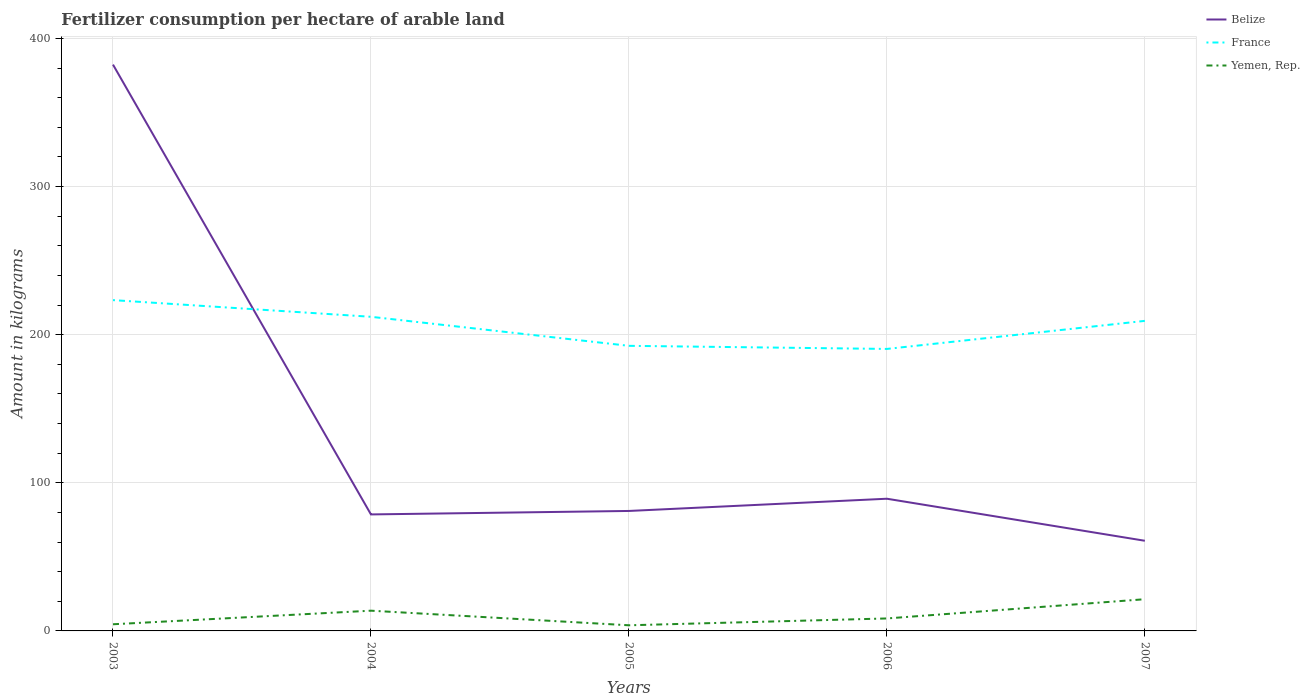How many different coloured lines are there?
Offer a very short reply. 3. Does the line corresponding to Belize intersect with the line corresponding to Yemen, Rep.?
Your answer should be compact. No. Across all years, what is the maximum amount of fertilizer consumption in France?
Your answer should be compact. 190.39. In which year was the amount of fertilizer consumption in Yemen, Rep. maximum?
Your response must be concise. 2005. What is the total amount of fertilizer consumption in Belize in the graph?
Ensure brevity in your answer.  321.5. What is the difference between the highest and the second highest amount of fertilizer consumption in France?
Your response must be concise. 32.96. What is the difference between the highest and the lowest amount of fertilizer consumption in France?
Your answer should be very brief. 3. How many lines are there?
Keep it short and to the point. 3. Are the values on the major ticks of Y-axis written in scientific E-notation?
Your answer should be very brief. No. How many legend labels are there?
Keep it short and to the point. 3. What is the title of the graph?
Keep it short and to the point. Fertilizer consumption per hectare of arable land. What is the label or title of the Y-axis?
Keep it short and to the point. Amount in kilograms. What is the Amount in kilograms of Belize in 2003?
Keep it short and to the point. 382.37. What is the Amount in kilograms of France in 2003?
Your answer should be very brief. 223.36. What is the Amount in kilograms in Yemen, Rep. in 2003?
Provide a short and direct response. 4.5. What is the Amount in kilograms of Belize in 2004?
Provide a short and direct response. 78.66. What is the Amount in kilograms of France in 2004?
Keep it short and to the point. 212.1. What is the Amount in kilograms in Yemen, Rep. in 2004?
Offer a terse response. 13.66. What is the Amount in kilograms in France in 2005?
Offer a terse response. 192.49. What is the Amount in kilograms of Yemen, Rep. in 2005?
Give a very brief answer. 3.81. What is the Amount in kilograms in Belize in 2006?
Offer a terse response. 89.26. What is the Amount in kilograms of France in 2006?
Offer a very short reply. 190.39. What is the Amount in kilograms of Yemen, Rep. in 2006?
Your answer should be compact. 8.42. What is the Amount in kilograms of Belize in 2007?
Give a very brief answer. 60.87. What is the Amount in kilograms in France in 2007?
Offer a very short reply. 209.34. What is the Amount in kilograms in Yemen, Rep. in 2007?
Ensure brevity in your answer.  21.41. Across all years, what is the maximum Amount in kilograms of Belize?
Your answer should be compact. 382.37. Across all years, what is the maximum Amount in kilograms of France?
Offer a terse response. 223.36. Across all years, what is the maximum Amount in kilograms in Yemen, Rep.?
Offer a very short reply. 21.41. Across all years, what is the minimum Amount in kilograms of Belize?
Ensure brevity in your answer.  60.87. Across all years, what is the minimum Amount in kilograms in France?
Keep it short and to the point. 190.39. Across all years, what is the minimum Amount in kilograms of Yemen, Rep.?
Your answer should be very brief. 3.81. What is the total Amount in kilograms in Belize in the graph?
Provide a short and direct response. 692.16. What is the total Amount in kilograms in France in the graph?
Give a very brief answer. 1027.69. What is the total Amount in kilograms of Yemen, Rep. in the graph?
Provide a succinct answer. 51.8. What is the difference between the Amount in kilograms of Belize in 2003 and that in 2004?
Provide a succinct answer. 303.71. What is the difference between the Amount in kilograms of France in 2003 and that in 2004?
Your response must be concise. 11.25. What is the difference between the Amount in kilograms of Yemen, Rep. in 2003 and that in 2004?
Keep it short and to the point. -9.17. What is the difference between the Amount in kilograms in Belize in 2003 and that in 2005?
Keep it short and to the point. 301.37. What is the difference between the Amount in kilograms in France in 2003 and that in 2005?
Offer a terse response. 30.86. What is the difference between the Amount in kilograms of Yemen, Rep. in 2003 and that in 2005?
Your response must be concise. 0.69. What is the difference between the Amount in kilograms in Belize in 2003 and that in 2006?
Keep it short and to the point. 293.11. What is the difference between the Amount in kilograms in France in 2003 and that in 2006?
Provide a short and direct response. 32.96. What is the difference between the Amount in kilograms in Yemen, Rep. in 2003 and that in 2006?
Your response must be concise. -3.93. What is the difference between the Amount in kilograms of Belize in 2003 and that in 2007?
Your answer should be compact. 321.5. What is the difference between the Amount in kilograms in France in 2003 and that in 2007?
Keep it short and to the point. 14.01. What is the difference between the Amount in kilograms in Yemen, Rep. in 2003 and that in 2007?
Ensure brevity in your answer.  -16.91. What is the difference between the Amount in kilograms in Belize in 2004 and that in 2005?
Provide a short and direct response. -2.34. What is the difference between the Amount in kilograms in France in 2004 and that in 2005?
Make the answer very short. 19.61. What is the difference between the Amount in kilograms in Yemen, Rep. in 2004 and that in 2005?
Your response must be concise. 9.86. What is the difference between the Amount in kilograms in France in 2004 and that in 2006?
Provide a short and direct response. 21.71. What is the difference between the Amount in kilograms in Yemen, Rep. in 2004 and that in 2006?
Your answer should be compact. 5.24. What is the difference between the Amount in kilograms in Belize in 2004 and that in 2007?
Your answer should be compact. 17.79. What is the difference between the Amount in kilograms of France in 2004 and that in 2007?
Your answer should be very brief. 2.76. What is the difference between the Amount in kilograms of Yemen, Rep. in 2004 and that in 2007?
Make the answer very short. -7.74. What is the difference between the Amount in kilograms in Belize in 2005 and that in 2006?
Provide a succinct answer. -8.26. What is the difference between the Amount in kilograms of Yemen, Rep. in 2005 and that in 2006?
Provide a succinct answer. -4.62. What is the difference between the Amount in kilograms of Belize in 2005 and that in 2007?
Offer a very short reply. 20.13. What is the difference between the Amount in kilograms in France in 2005 and that in 2007?
Offer a terse response. -16.85. What is the difference between the Amount in kilograms of Yemen, Rep. in 2005 and that in 2007?
Your answer should be compact. -17.6. What is the difference between the Amount in kilograms of Belize in 2006 and that in 2007?
Offer a very short reply. 28.39. What is the difference between the Amount in kilograms of France in 2006 and that in 2007?
Your response must be concise. -18.95. What is the difference between the Amount in kilograms in Yemen, Rep. in 2006 and that in 2007?
Provide a short and direct response. -12.98. What is the difference between the Amount in kilograms in Belize in 2003 and the Amount in kilograms in France in 2004?
Keep it short and to the point. 170.27. What is the difference between the Amount in kilograms of Belize in 2003 and the Amount in kilograms of Yemen, Rep. in 2004?
Your answer should be very brief. 368.71. What is the difference between the Amount in kilograms in France in 2003 and the Amount in kilograms in Yemen, Rep. in 2004?
Your response must be concise. 209.69. What is the difference between the Amount in kilograms of Belize in 2003 and the Amount in kilograms of France in 2005?
Keep it short and to the point. 189.88. What is the difference between the Amount in kilograms of Belize in 2003 and the Amount in kilograms of Yemen, Rep. in 2005?
Give a very brief answer. 378.56. What is the difference between the Amount in kilograms in France in 2003 and the Amount in kilograms in Yemen, Rep. in 2005?
Give a very brief answer. 219.55. What is the difference between the Amount in kilograms of Belize in 2003 and the Amount in kilograms of France in 2006?
Your answer should be compact. 191.98. What is the difference between the Amount in kilograms of Belize in 2003 and the Amount in kilograms of Yemen, Rep. in 2006?
Give a very brief answer. 373.95. What is the difference between the Amount in kilograms of France in 2003 and the Amount in kilograms of Yemen, Rep. in 2006?
Offer a terse response. 214.93. What is the difference between the Amount in kilograms in Belize in 2003 and the Amount in kilograms in France in 2007?
Your answer should be very brief. 173.03. What is the difference between the Amount in kilograms of Belize in 2003 and the Amount in kilograms of Yemen, Rep. in 2007?
Provide a succinct answer. 360.96. What is the difference between the Amount in kilograms of France in 2003 and the Amount in kilograms of Yemen, Rep. in 2007?
Your response must be concise. 201.95. What is the difference between the Amount in kilograms in Belize in 2004 and the Amount in kilograms in France in 2005?
Give a very brief answer. -113.84. What is the difference between the Amount in kilograms in Belize in 2004 and the Amount in kilograms in Yemen, Rep. in 2005?
Keep it short and to the point. 74.85. What is the difference between the Amount in kilograms in France in 2004 and the Amount in kilograms in Yemen, Rep. in 2005?
Your answer should be compact. 208.3. What is the difference between the Amount in kilograms in Belize in 2004 and the Amount in kilograms in France in 2006?
Offer a very short reply. -111.74. What is the difference between the Amount in kilograms in Belize in 2004 and the Amount in kilograms in Yemen, Rep. in 2006?
Make the answer very short. 70.23. What is the difference between the Amount in kilograms in France in 2004 and the Amount in kilograms in Yemen, Rep. in 2006?
Offer a very short reply. 203.68. What is the difference between the Amount in kilograms in Belize in 2004 and the Amount in kilograms in France in 2007?
Keep it short and to the point. -130.69. What is the difference between the Amount in kilograms in Belize in 2004 and the Amount in kilograms in Yemen, Rep. in 2007?
Your answer should be compact. 57.25. What is the difference between the Amount in kilograms in France in 2004 and the Amount in kilograms in Yemen, Rep. in 2007?
Make the answer very short. 190.7. What is the difference between the Amount in kilograms of Belize in 2005 and the Amount in kilograms of France in 2006?
Your response must be concise. -109.39. What is the difference between the Amount in kilograms of Belize in 2005 and the Amount in kilograms of Yemen, Rep. in 2006?
Offer a terse response. 72.58. What is the difference between the Amount in kilograms of France in 2005 and the Amount in kilograms of Yemen, Rep. in 2006?
Your answer should be compact. 184.07. What is the difference between the Amount in kilograms in Belize in 2005 and the Amount in kilograms in France in 2007?
Your response must be concise. -128.34. What is the difference between the Amount in kilograms of Belize in 2005 and the Amount in kilograms of Yemen, Rep. in 2007?
Give a very brief answer. 59.59. What is the difference between the Amount in kilograms of France in 2005 and the Amount in kilograms of Yemen, Rep. in 2007?
Ensure brevity in your answer.  171.09. What is the difference between the Amount in kilograms in Belize in 2006 and the Amount in kilograms in France in 2007?
Your answer should be very brief. -120.09. What is the difference between the Amount in kilograms of Belize in 2006 and the Amount in kilograms of Yemen, Rep. in 2007?
Provide a short and direct response. 67.85. What is the difference between the Amount in kilograms in France in 2006 and the Amount in kilograms in Yemen, Rep. in 2007?
Provide a short and direct response. 168.99. What is the average Amount in kilograms in Belize per year?
Offer a terse response. 138.43. What is the average Amount in kilograms in France per year?
Keep it short and to the point. 205.54. What is the average Amount in kilograms of Yemen, Rep. per year?
Keep it short and to the point. 10.36. In the year 2003, what is the difference between the Amount in kilograms in Belize and Amount in kilograms in France?
Your answer should be very brief. 159.02. In the year 2003, what is the difference between the Amount in kilograms of Belize and Amount in kilograms of Yemen, Rep.?
Give a very brief answer. 377.87. In the year 2003, what is the difference between the Amount in kilograms in France and Amount in kilograms in Yemen, Rep.?
Ensure brevity in your answer.  218.86. In the year 2004, what is the difference between the Amount in kilograms of Belize and Amount in kilograms of France?
Your answer should be very brief. -133.45. In the year 2004, what is the difference between the Amount in kilograms in Belize and Amount in kilograms in Yemen, Rep.?
Keep it short and to the point. 64.99. In the year 2004, what is the difference between the Amount in kilograms of France and Amount in kilograms of Yemen, Rep.?
Offer a very short reply. 198.44. In the year 2005, what is the difference between the Amount in kilograms in Belize and Amount in kilograms in France?
Ensure brevity in your answer.  -111.49. In the year 2005, what is the difference between the Amount in kilograms in Belize and Amount in kilograms in Yemen, Rep.?
Provide a short and direct response. 77.19. In the year 2005, what is the difference between the Amount in kilograms of France and Amount in kilograms of Yemen, Rep.?
Your answer should be compact. 188.69. In the year 2006, what is the difference between the Amount in kilograms in Belize and Amount in kilograms in France?
Keep it short and to the point. -101.14. In the year 2006, what is the difference between the Amount in kilograms of Belize and Amount in kilograms of Yemen, Rep.?
Your answer should be very brief. 80.83. In the year 2006, what is the difference between the Amount in kilograms in France and Amount in kilograms in Yemen, Rep.?
Provide a short and direct response. 181.97. In the year 2007, what is the difference between the Amount in kilograms of Belize and Amount in kilograms of France?
Give a very brief answer. -148.47. In the year 2007, what is the difference between the Amount in kilograms of Belize and Amount in kilograms of Yemen, Rep.?
Keep it short and to the point. 39.46. In the year 2007, what is the difference between the Amount in kilograms of France and Amount in kilograms of Yemen, Rep.?
Give a very brief answer. 187.94. What is the ratio of the Amount in kilograms of Belize in 2003 to that in 2004?
Make the answer very short. 4.86. What is the ratio of the Amount in kilograms of France in 2003 to that in 2004?
Ensure brevity in your answer.  1.05. What is the ratio of the Amount in kilograms of Yemen, Rep. in 2003 to that in 2004?
Provide a succinct answer. 0.33. What is the ratio of the Amount in kilograms of Belize in 2003 to that in 2005?
Give a very brief answer. 4.72. What is the ratio of the Amount in kilograms in France in 2003 to that in 2005?
Make the answer very short. 1.16. What is the ratio of the Amount in kilograms of Yemen, Rep. in 2003 to that in 2005?
Offer a terse response. 1.18. What is the ratio of the Amount in kilograms in Belize in 2003 to that in 2006?
Keep it short and to the point. 4.28. What is the ratio of the Amount in kilograms of France in 2003 to that in 2006?
Your answer should be compact. 1.17. What is the ratio of the Amount in kilograms in Yemen, Rep. in 2003 to that in 2006?
Ensure brevity in your answer.  0.53. What is the ratio of the Amount in kilograms in Belize in 2003 to that in 2007?
Provide a succinct answer. 6.28. What is the ratio of the Amount in kilograms of France in 2003 to that in 2007?
Give a very brief answer. 1.07. What is the ratio of the Amount in kilograms in Yemen, Rep. in 2003 to that in 2007?
Your answer should be compact. 0.21. What is the ratio of the Amount in kilograms in Belize in 2004 to that in 2005?
Provide a succinct answer. 0.97. What is the ratio of the Amount in kilograms in France in 2004 to that in 2005?
Provide a succinct answer. 1.1. What is the ratio of the Amount in kilograms in Yemen, Rep. in 2004 to that in 2005?
Your answer should be very brief. 3.59. What is the ratio of the Amount in kilograms in Belize in 2004 to that in 2006?
Provide a short and direct response. 0.88. What is the ratio of the Amount in kilograms in France in 2004 to that in 2006?
Ensure brevity in your answer.  1.11. What is the ratio of the Amount in kilograms in Yemen, Rep. in 2004 to that in 2006?
Your answer should be very brief. 1.62. What is the ratio of the Amount in kilograms of Belize in 2004 to that in 2007?
Keep it short and to the point. 1.29. What is the ratio of the Amount in kilograms of France in 2004 to that in 2007?
Make the answer very short. 1.01. What is the ratio of the Amount in kilograms of Yemen, Rep. in 2004 to that in 2007?
Keep it short and to the point. 0.64. What is the ratio of the Amount in kilograms of Belize in 2005 to that in 2006?
Keep it short and to the point. 0.91. What is the ratio of the Amount in kilograms of France in 2005 to that in 2006?
Make the answer very short. 1.01. What is the ratio of the Amount in kilograms of Yemen, Rep. in 2005 to that in 2006?
Give a very brief answer. 0.45. What is the ratio of the Amount in kilograms in Belize in 2005 to that in 2007?
Keep it short and to the point. 1.33. What is the ratio of the Amount in kilograms of France in 2005 to that in 2007?
Offer a terse response. 0.92. What is the ratio of the Amount in kilograms of Yemen, Rep. in 2005 to that in 2007?
Keep it short and to the point. 0.18. What is the ratio of the Amount in kilograms of Belize in 2006 to that in 2007?
Provide a succinct answer. 1.47. What is the ratio of the Amount in kilograms of France in 2006 to that in 2007?
Keep it short and to the point. 0.91. What is the ratio of the Amount in kilograms of Yemen, Rep. in 2006 to that in 2007?
Ensure brevity in your answer.  0.39. What is the difference between the highest and the second highest Amount in kilograms in Belize?
Your answer should be compact. 293.11. What is the difference between the highest and the second highest Amount in kilograms of France?
Provide a succinct answer. 11.25. What is the difference between the highest and the second highest Amount in kilograms in Yemen, Rep.?
Make the answer very short. 7.74. What is the difference between the highest and the lowest Amount in kilograms of Belize?
Provide a short and direct response. 321.5. What is the difference between the highest and the lowest Amount in kilograms in France?
Provide a succinct answer. 32.96. What is the difference between the highest and the lowest Amount in kilograms of Yemen, Rep.?
Your response must be concise. 17.6. 